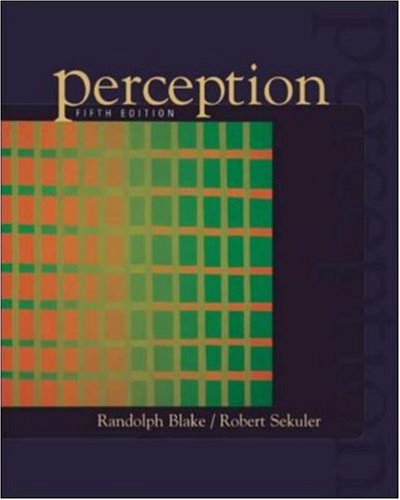Is this a judicial book? No, this book is not related to judicial matters. It focuses on psychological and perceptual studies. 